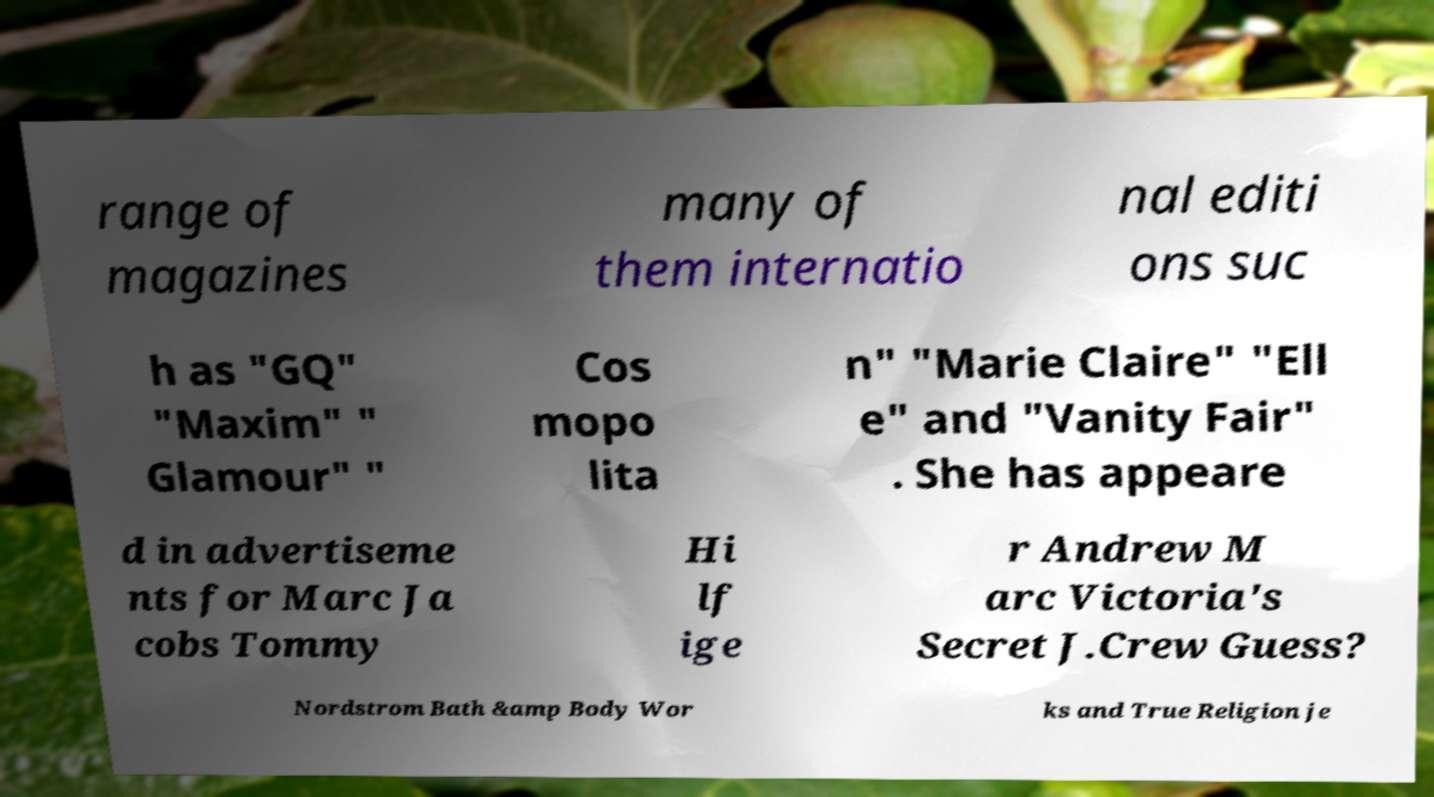Can you accurately transcribe the text from the provided image for me? range of magazines many of them internatio nal editi ons suc h as "GQ" "Maxim" " Glamour" " Cos mopo lita n" "Marie Claire" "Ell e" and "Vanity Fair" . She has appeare d in advertiseme nts for Marc Ja cobs Tommy Hi lf ige r Andrew M arc Victoria's Secret J.Crew Guess? Nordstrom Bath &amp Body Wor ks and True Religion je 